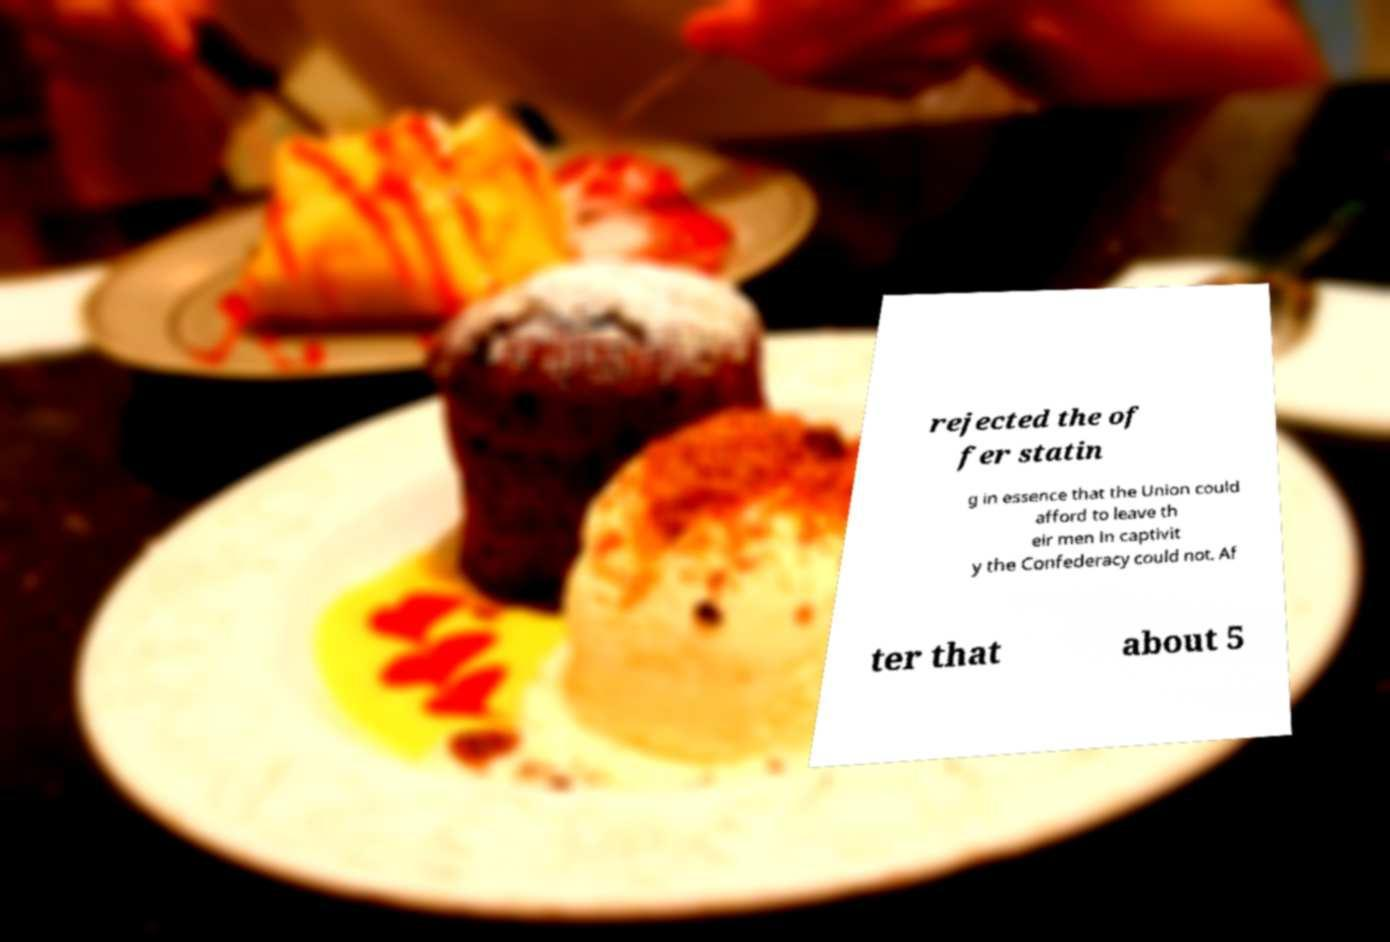Please identify and transcribe the text found in this image. rejected the of fer statin g in essence that the Union could afford to leave th eir men in captivit y the Confederacy could not. Af ter that about 5 